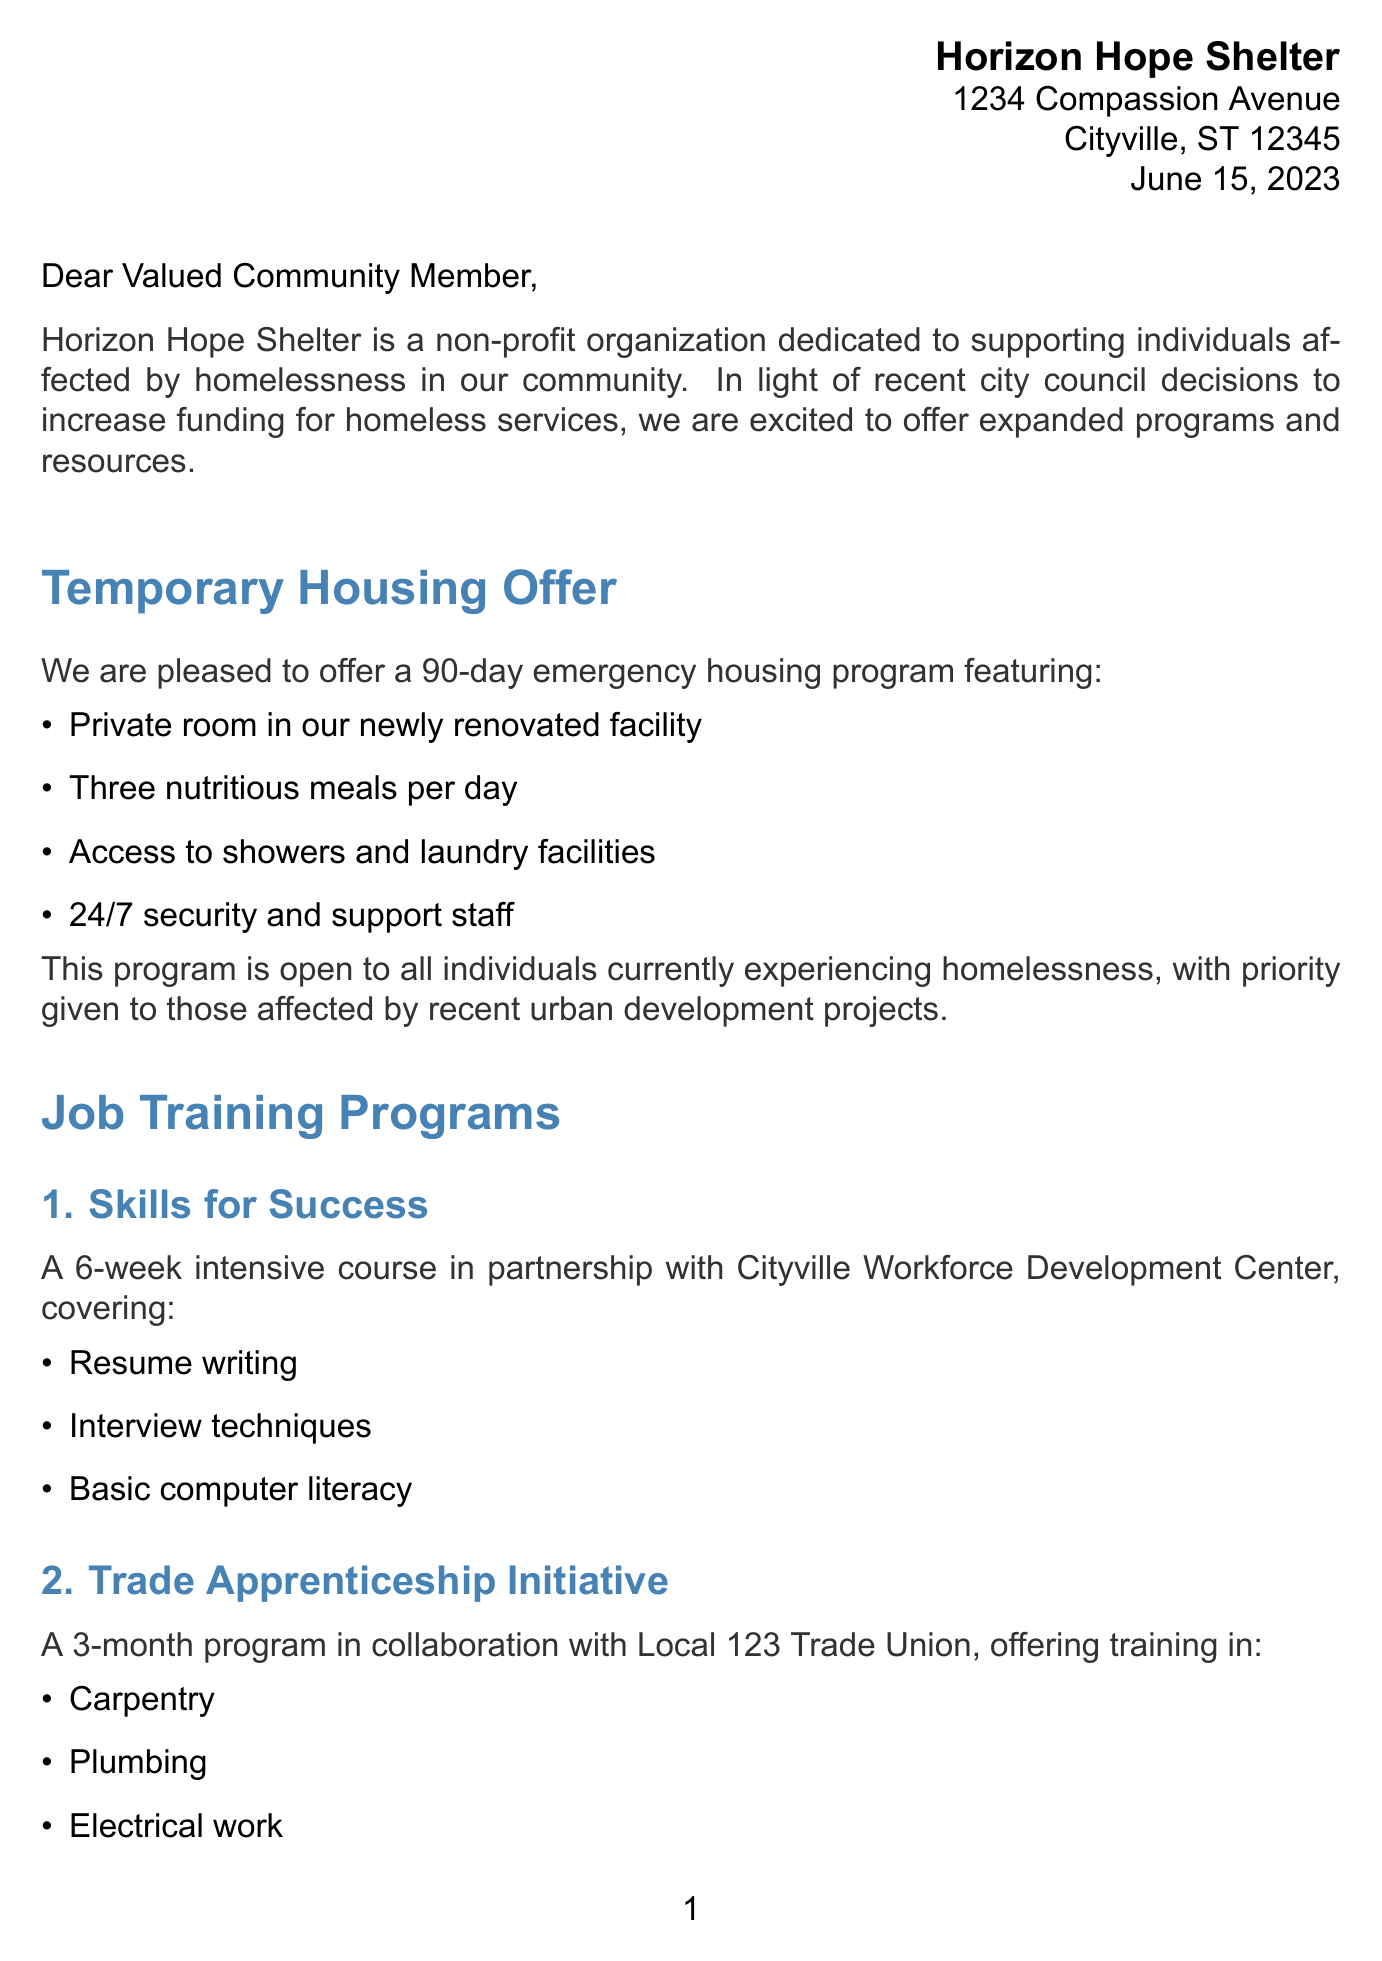What is the name of the shelter? The shelter's name is mentioned in the header of the document.
Answer: Horizon Hope Shelter What is the address of the shelter? The address is provided in the header section of the letter.
Answer: 1234 Compassion Avenue, Cityville, ST 12345 What is the duration of the temporary housing program? The duration can be found in the section describing the temporary housing offer.
Answer: 90-day emergency housing program What amenities are included in the temporary housing? The document lists several amenities under the temporary housing offer section.
Answer: Three nutritious meals per day, Access to showers and laundry facilities, 24/7 security and support staff What is the name of the first job training program? The first program is specifically named in the job training section of the letter.
Answer: Skills for Success How long is the "Trade Apprenticeship Initiative" program? The duration of the program can be found in the job training programs section.
Answer: 3-month program What type of assistance does the shelter offer for mental health? The shelter's additional services include different assistance programs that are listed.
Answer: Mental health counseling through partnership with Mindful Health Clinic What is the first step in the application process? The application process is clearly outlined in the respective section of the document.
Answer: Visit our intake office at 1234 Compassion Avenue What is the phone number to contact the shelter? The contact information at the end of the letter provides this detail.
Answer: (555) 123-4567 What message does the letter convey at the end? The closing of the letter includes a supportive message to the community.
Answer: We understand the challenges you face and are here to support you on your journey to stability and self-sufficiency 